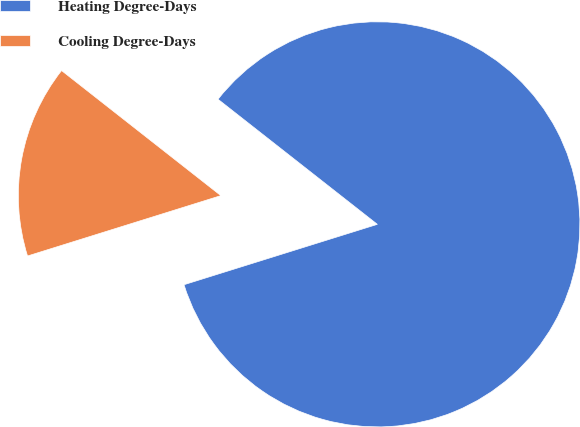Convert chart. <chart><loc_0><loc_0><loc_500><loc_500><pie_chart><fcel>Heating Degree-Days<fcel>Cooling Degree-Days<nl><fcel>84.59%<fcel>15.41%<nl></chart> 